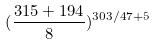Convert formula to latex. <formula><loc_0><loc_0><loc_500><loc_500>( \frac { 3 1 5 + 1 9 4 } { 8 } ) ^ { 3 0 3 / 4 7 + 5 }</formula> 